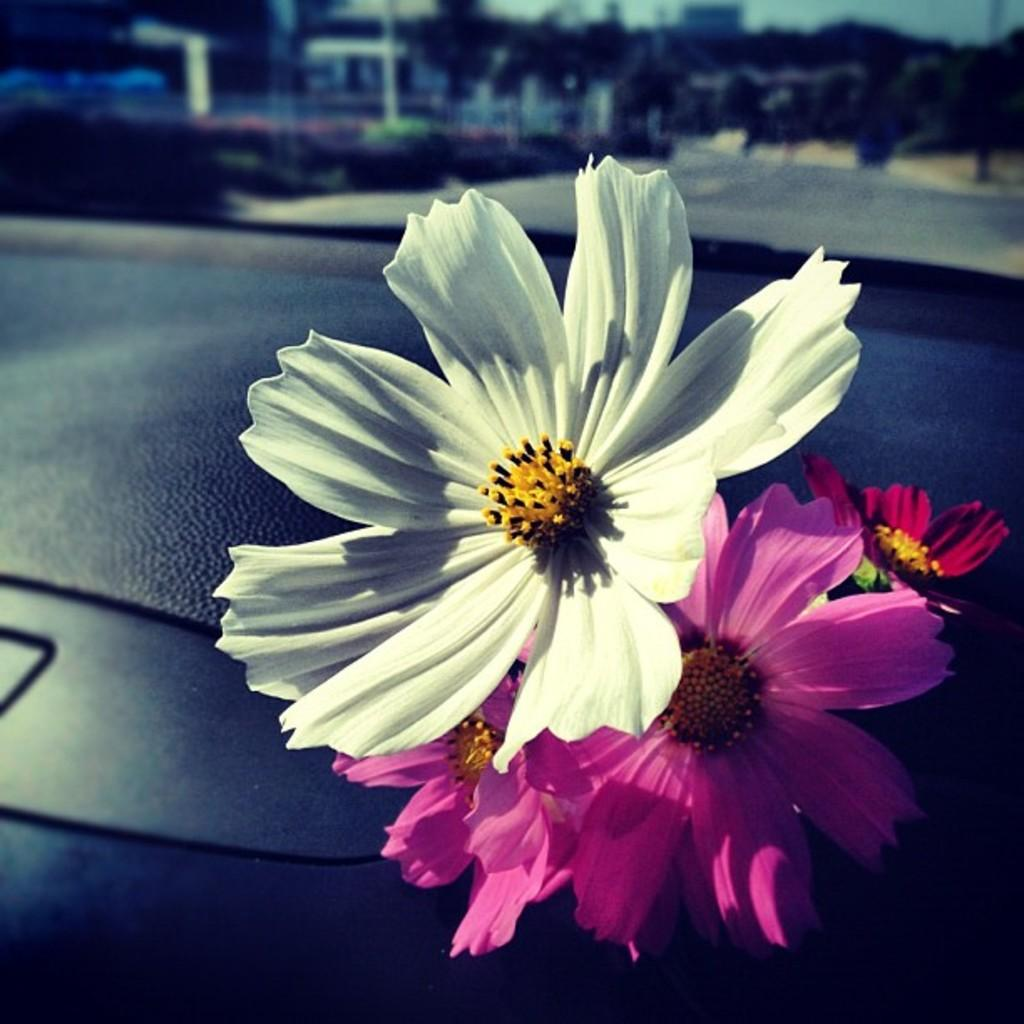What is placed on the plastic surface in the image? There are flowers on a plastic surface in the image. What can be seen in the background of the image? The sky and trees are visible in the background of the image. What type of toys can be seen playing with the clam in the image? There are no toys or clams present in the image; it features flowers on a plastic surface and a background with the sky and trees. 